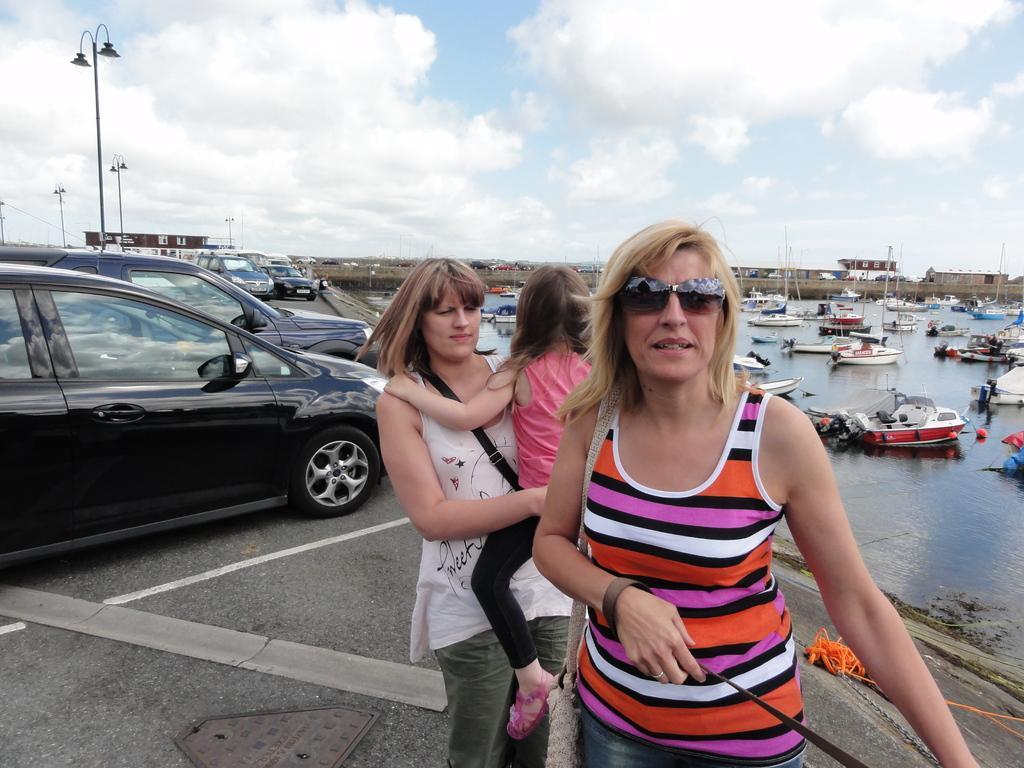How would you summarize this image in a sentence or two? In this picture I can observe two women and a girl. One of them is wearing spectacles. On the left side, some cars are parked in the parking lot. On the right side, I can observe fleet in the river. In the background I can observe some clouds in the sky. 